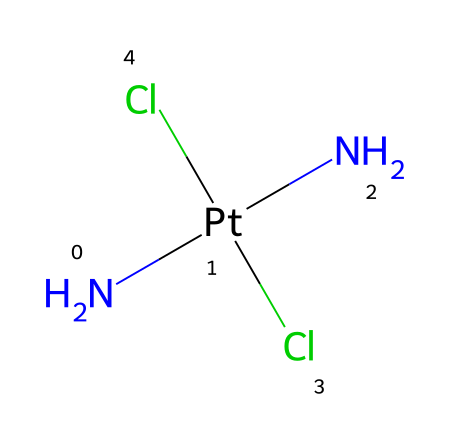What is the central atom in this chemical? The structure shows a platinum atom (Pt) in the center, which is bonded to other groups, making it the central atom of the molecule.
Answer: platinum How many nitrogen atoms are present in this chemical? By examining the SMILES notation, there are two nitrogen atoms attached to the platinum atom (N[Pt](N)...) indicating the presence of two nitrogen atoms.
Answer: two What type of halogen is indicated in the structure of this chemical? The chemical has two chloride (Cl) atoms as indicated by their presence in the SMILES notation. Chlorine is a halogen, thus the structure contains halogen elements.
Answer: chloride What is the coordination number of the platinum in this chemical? The platinum atom is coordinated to two nitrogen atoms and two chlorine atoms, making a total of four ligands bonded to platinum. Therefore, the coordination number is calculated as four.
Answer: four What kind of bonding is likely to occur between platinum and nitrogen in this chemical? The bonding between platinum and nitrogen is characterized by coordination bonding, which is typical for complexes involving transition metals like platinum with nitrogen donors.
Answer: coordination Why might this compound be effective as a DNA cross-linking agent? The presence of platinum facilitates the formation of covalent bonds with DNA nucleophiles, which can lead to the cross-linking of DNA strands effectively, disrupting DNA replication and function.
Answer: covalent bonds 